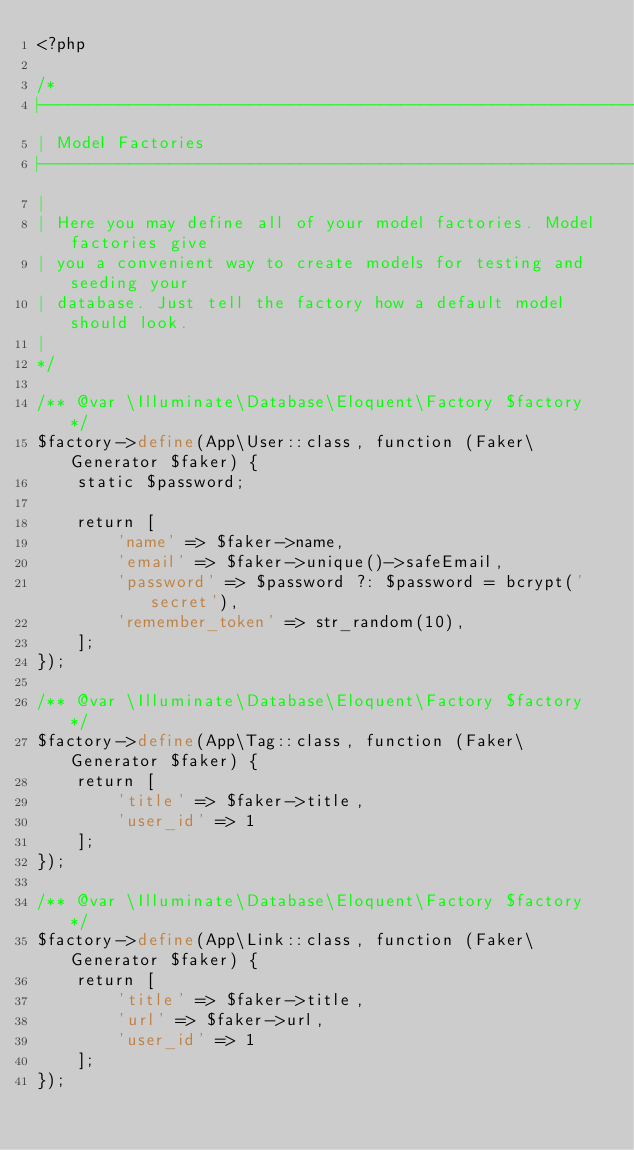Convert code to text. <code><loc_0><loc_0><loc_500><loc_500><_PHP_><?php

/*
|--------------------------------------------------------------------------
| Model Factories
|--------------------------------------------------------------------------
|
| Here you may define all of your model factories. Model factories give
| you a convenient way to create models for testing and seeding your
| database. Just tell the factory how a default model should look.
|
*/

/** @var \Illuminate\Database\Eloquent\Factory $factory */
$factory->define(App\User::class, function (Faker\Generator $faker) {
    static $password;

    return [
        'name' => $faker->name,
        'email' => $faker->unique()->safeEmail,
        'password' => $password ?: $password = bcrypt('secret'),
        'remember_token' => str_random(10),
    ];
});

/** @var \Illuminate\Database\Eloquent\Factory $factory */
$factory->define(App\Tag::class, function (Faker\Generator $faker) {
	return [
		'title' => $faker->title,
		'user_id' => 1
	];
});

/** @var \Illuminate\Database\Eloquent\Factory $factory */
$factory->define(App\Link::class, function (Faker\Generator $faker) {
	return [
		'title' => $faker->title,
		'url' => $faker->url,
		'user_id' => 1
	];
});</code> 